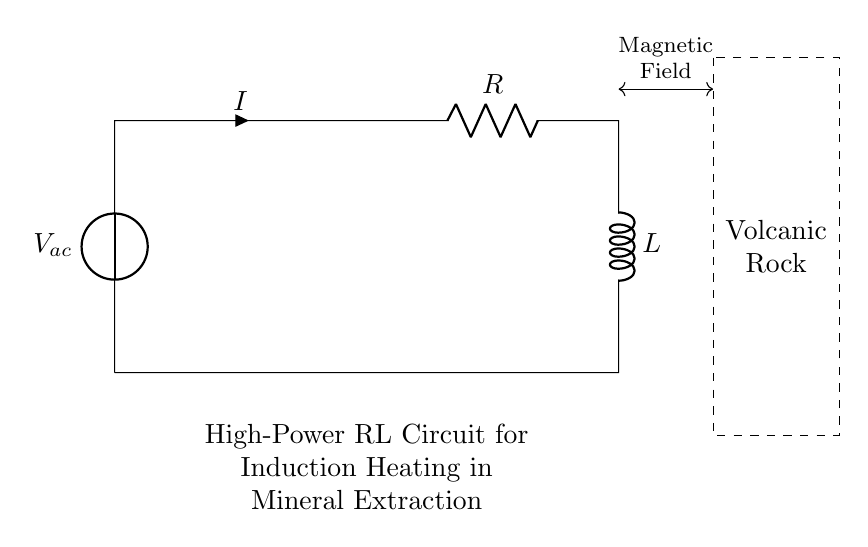What is the type of voltage source in this circuit? The circuit has an AC voltage source, which is indicated by the symbol used for the voltage source labeled V_{ac}. The designation "ac" specifies that it is alternating current.
Answer: AC What are the components in the circuit? The circuit includes a voltage source labeled V_{ac}, a resistor labeled R, and an inductor labeled L. These are the primary components shown in the diagram.
Answer: Voltage source, resistor, inductor What is the direction of the current in this circuit? The current direction is indicated by the arrow labeled I, flowing from the voltage source upwards through the resistor and then down into the inductor. The flow creates a closed loop with the circuit.
Answer: Clockwise What is the function of the inductor in this circuit? The inductor is used primarily for creating a magnetic field, which is crucial for induction heating. It stores energy in its magnetic field when current flows through it. This is essential for the heating process in mineral extraction.
Answer: Creates magnetic field How does the resistor affect the circuit's performance? The resistor introduces a resistive element to the circuit, which affects the voltage drop and current flow. It limits the amount of current that can pass through, which can optimize the heating process without excessive energy loss.
Answer: Limits current What is the role of the dashed rectangle in the circuit? The dashed rectangle indicates the area or material being affected by the magnetic field, which in this case is the volcanic rock. This notation emphasizes the interaction between the circuit and the material for induction heating purposes.
Answer: Volcanic rock What is the expected outcome of this circuit configuration? The expected outcome is the induction heating of the volcanic rock, which allows for the effective extraction of valuable minerals. The interaction between the magnetic field produced by the inductor and the rock facilitates this heating.
Answer: Induction heating 